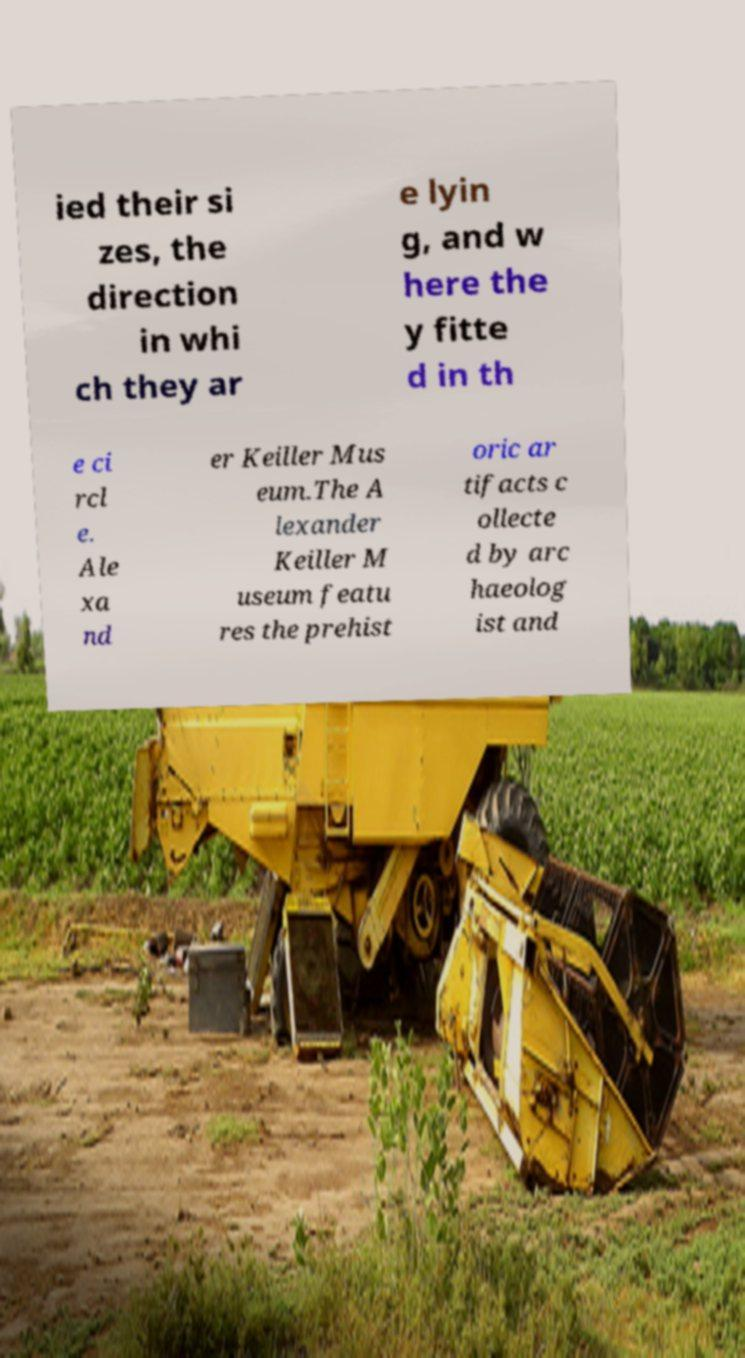There's text embedded in this image that I need extracted. Can you transcribe it verbatim? ied their si zes, the direction in whi ch they ar e lyin g, and w here the y fitte d in th e ci rcl e. Ale xa nd er Keiller Mus eum.The A lexander Keiller M useum featu res the prehist oric ar tifacts c ollecte d by arc haeolog ist and 